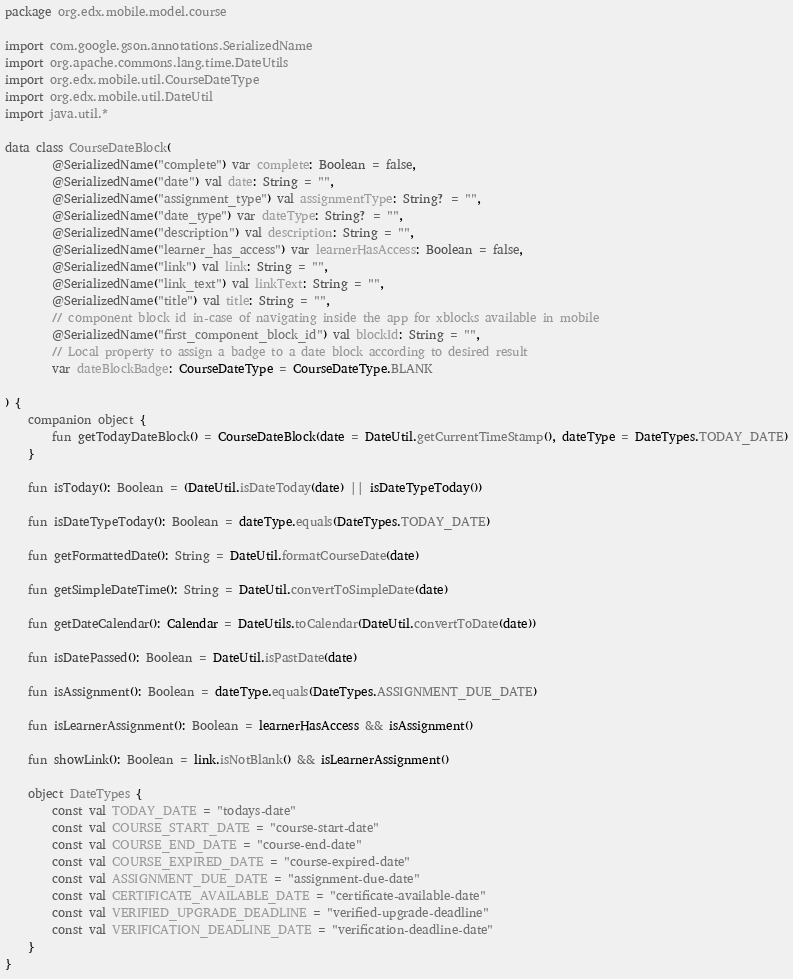<code> <loc_0><loc_0><loc_500><loc_500><_Kotlin_>package org.edx.mobile.model.course

import com.google.gson.annotations.SerializedName
import org.apache.commons.lang.time.DateUtils
import org.edx.mobile.util.CourseDateType
import org.edx.mobile.util.DateUtil
import java.util.*

data class CourseDateBlock(
        @SerializedName("complete") var complete: Boolean = false,
        @SerializedName("date") val date: String = "",
        @SerializedName("assignment_type") val assignmentType: String? = "",
        @SerializedName("date_type") var dateType: String? = "",
        @SerializedName("description") val description: String = "",
        @SerializedName("learner_has_access") var learnerHasAccess: Boolean = false,
        @SerializedName("link") val link: String = "",
        @SerializedName("link_text") val linkText: String = "",
        @SerializedName("title") val title: String = "",
        // component block id in-case of navigating inside the app for xblocks available in mobile
        @SerializedName("first_component_block_id") val blockId: String = "",
        // Local property to assign a badge to a date block according to desired result
        var dateBlockBadge: CourseDateType = CourseDateType.BLANK

) {
    companion object {
        fun getTodayDateBlock() = CourseDateBlock(date = DateUtil.getCurrentTimeStamp(), dateType = DateTypes.TODAY_DATE)
    }

    fun isToday(): Boolean = (DateUtil.isDateToday(date) || isDateTypeToday())

    fun isDateTypeToday(): Boolean = dateType.equals(DateTypes.TODAY_DATE)

    fun getFormattedDate(): String = DateUtil.formatCourseDate(date)

    fun getSimpleDateTime(): String = DateUtil.convertToSimpleDate(date)

    fun getDateCalendar(): Calendar = DateUtils.toCalendar(DateUtil.convertToDate(date))

    fun isDatePassed(): Boolean = DateUtil.isPastDate(date)

    fun isAssignment(): Boolean = dateType.equals(DateTypes.ASSIGNMENT_DUE_DATE)

    fun isLearnerAssignment(): Boolean = learnerHasAccess && isAssignment()

    fun showLink(): Boolean = link.isNotBlank() && isLearnerAssignment()

    object DateTypes {
        const val TODAY_DATE = "todays-date"
        const val COURSE_START_DATE = "course-start-date"
        const val COURSE_END_DATE = "course-end-date"
        const val COURSE_EXPIRED_DATE = "course-expired-date"
        const val ASSIGNMENT_DUE_DATE = "assignment-due-date"
        const val CERTIFICATE_AVAILABLE_DATE = "certificate-available-date"
        const val VERIFIED_UPGRADE_DEADLINE = "verified-upgrade-deadline"
        const val VERIFICATION_DEADLINE_DATE = "verification-deadline-date"
    }
}
</code> 